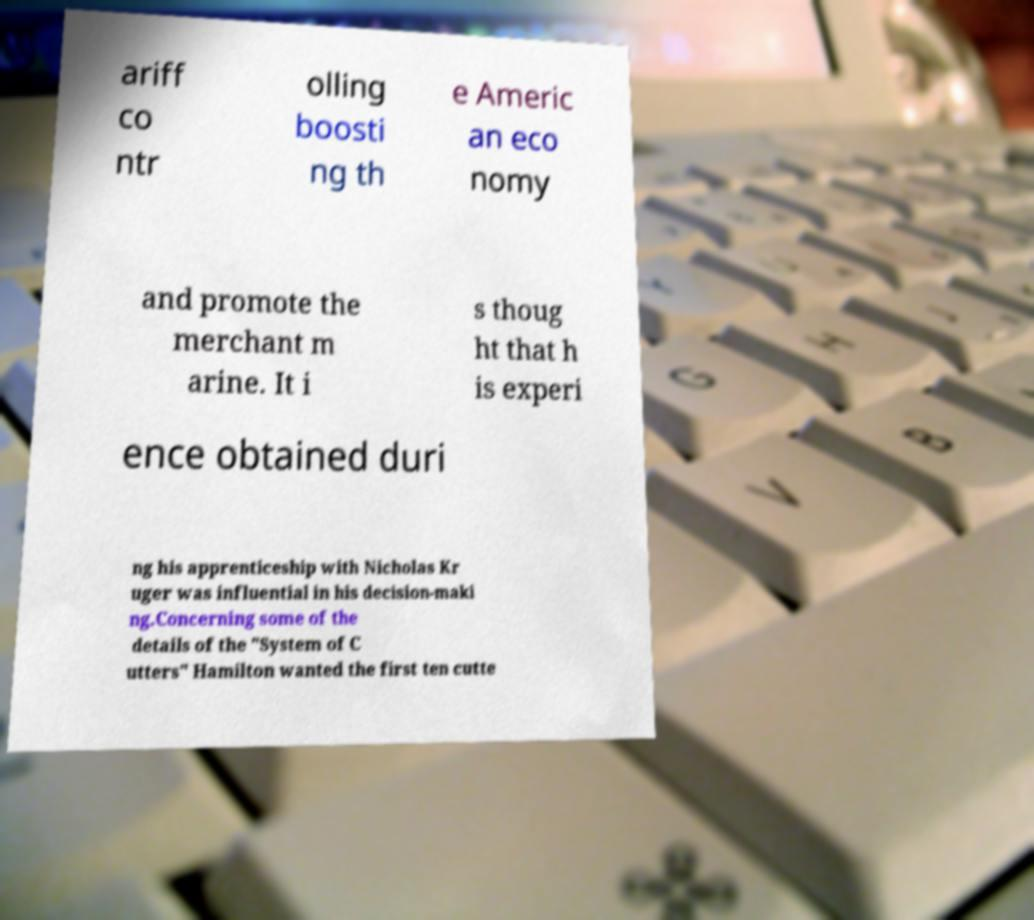Could you assist in decoding the text presented in this image and type it out clearly? ariff co ntr olling boosti ng th e Americ an eco nomy and promote the merchant m arine. It i s thoug ht that h is experi ence obtained duri ng his apprenticeship with Nicholas Kr uger was influential in his decision-maki ng.Concerning some of the details of the "System of C utters" Hamilton wanted the first ten cutte 